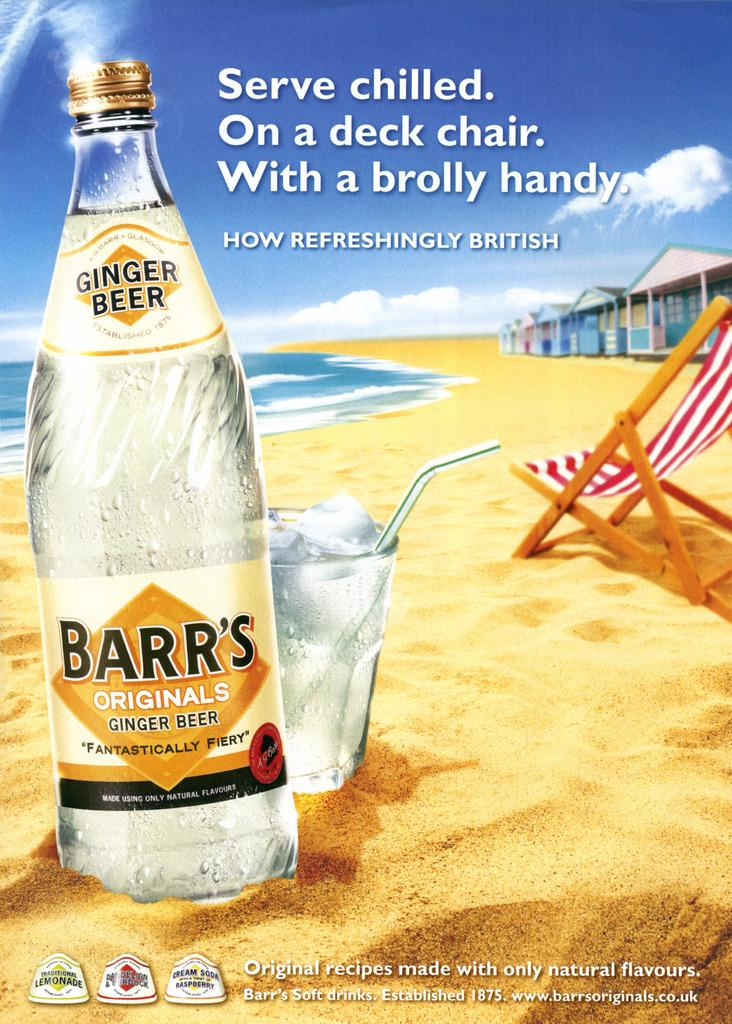<image>
Share a concise interpretation of the image provided. Advertisement of a ginger beer made by Barr's Originals 